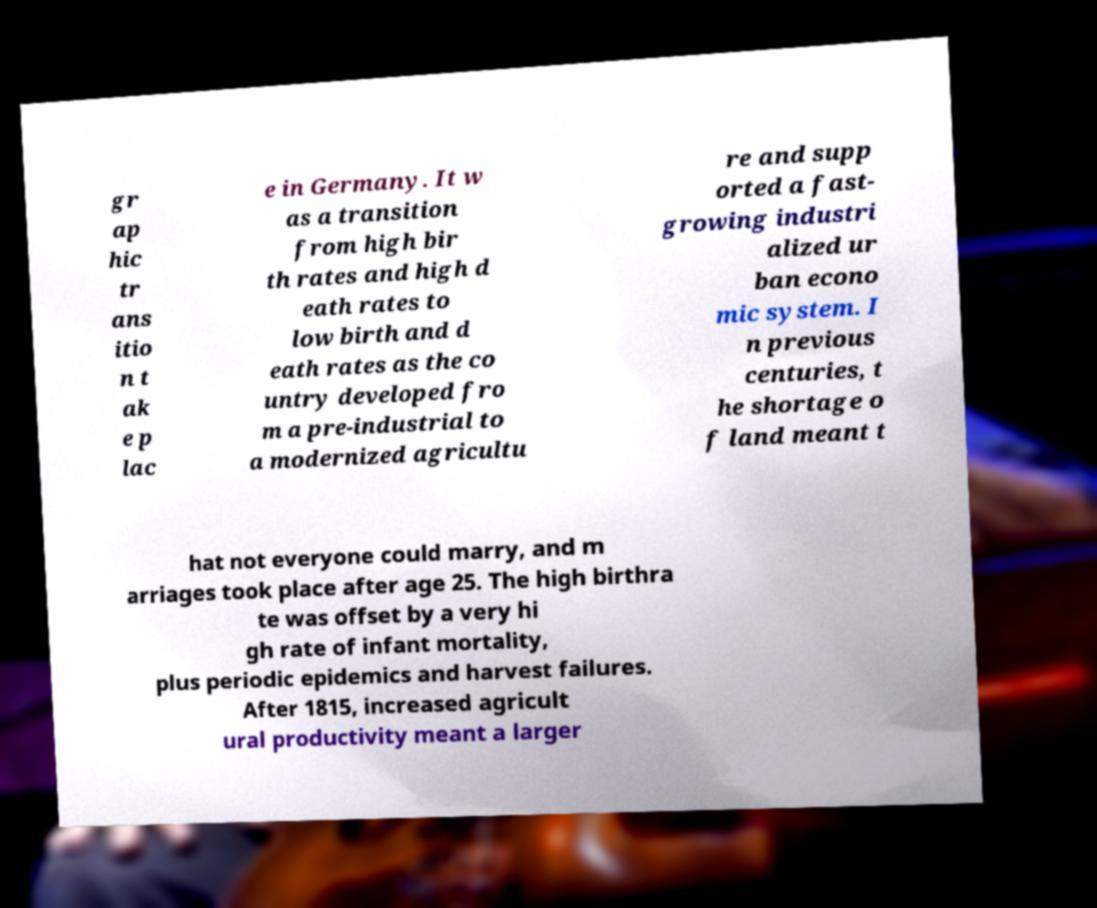Please identify and transcribe the text found in this image. gr ap hic tr ans itio n t ak e p lac e in Germany. It w as a transition from high bir th rates and high d eath rates to low birth and d eath rates as the co untry developed fro m a pre-industrial to a modernized agricultu re and supp orted a fast- growing industri alized ur ban econo mic system. I n previous centuries, t he shortage o f land meant t hat not everyone could marry, and m arriages took place after age 25. The high birthra te was offset by a very hi gh rate of infant mortality, plus periodic epidemics and harvest failures. After 1815, increased agricult ural productivity meant a larger 